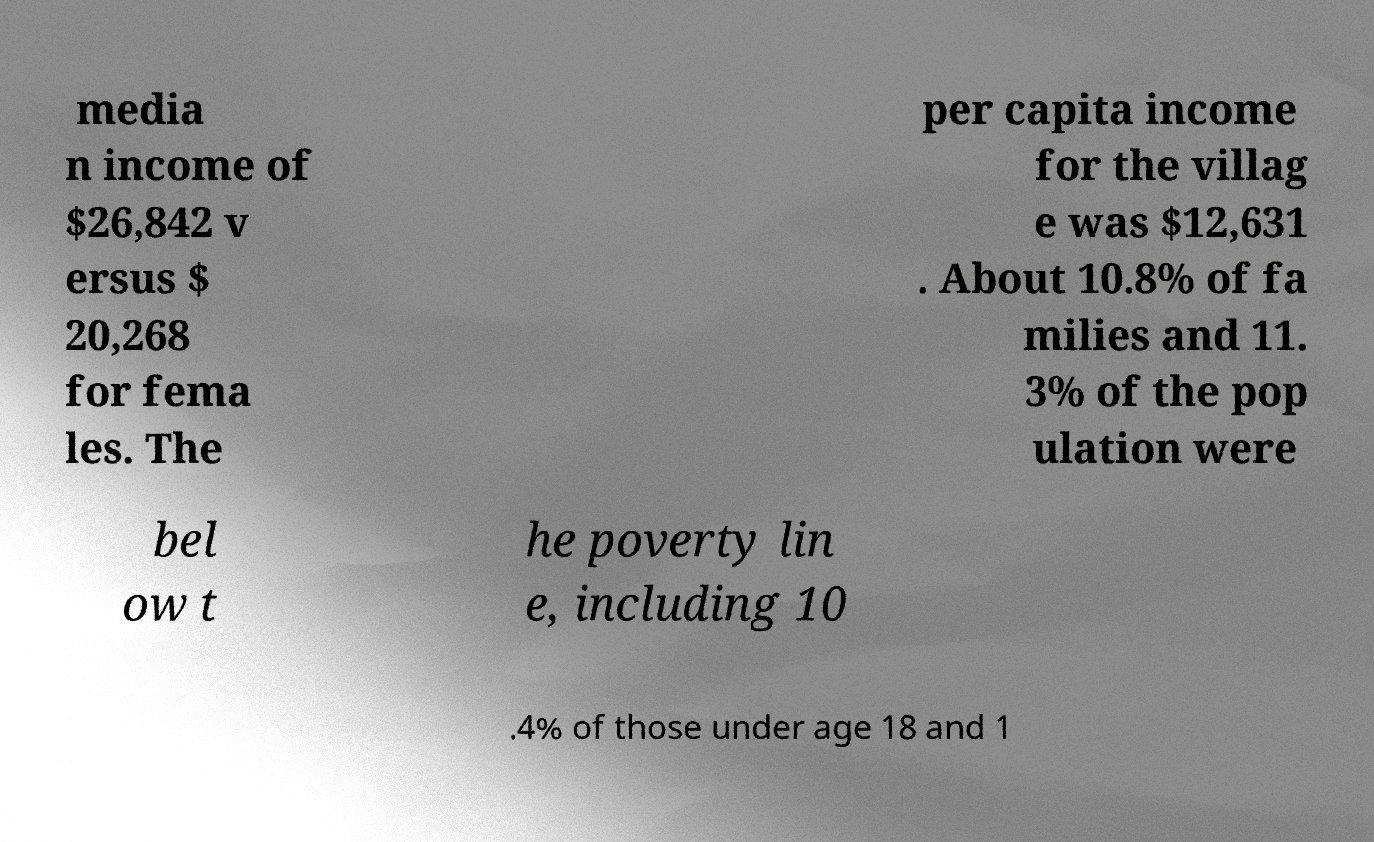Could you assist in decoding the text presented in this image and type it out clearly? media n income of $26,842 v ersus $ 20,268 for fema les. The per capita income for the villag e was $12,631 . About 10.8% of fa milies and 11. 3% of the pop ulation were bel ow t he poverty lin e, including 10 .4% of those under age 18 and 1 